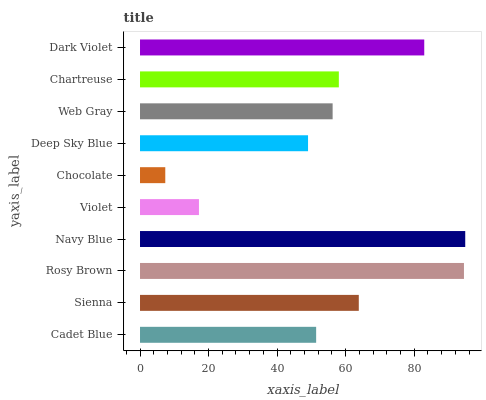Is Chocolate the minimum?
Answer yes or no. Yes. Is Navy Blue the maximum?
Answer yes or no. Yes. Is Sienna the minimum?
Answer yes or no. No. Is Sienna the maximum?
Answer yes or no. No. Is Sienna greater than Cadet Blue?
Answer yes or no. Yes. Is Cadet Blue less than Sienna?
Answer yes or no. Yes. Is Cadet Blue greater than Sienna?
Answer yes or no. No. Is Sienna less than Cadet Blue?
Answer yes or no. No. Is Chartreuse the high median?
Answer yes or no. Yes. Is Web Gray the low median?
Answer yes or no. Yes. Is Cadet Blue the high median?
Answer yes or no. No. Is Deep Sky Blue the low median?
Answer yes or no. No. 